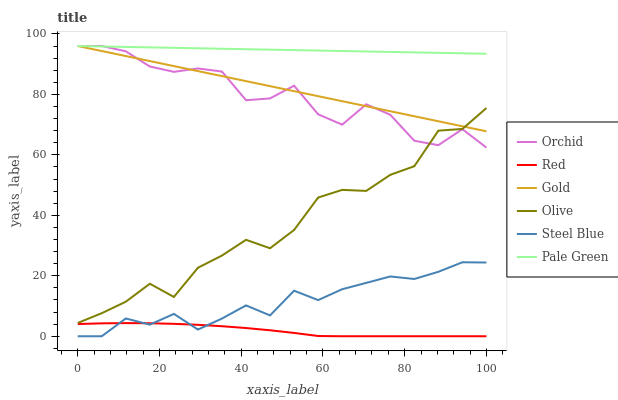Does Steel Blue have the minimum area under the curve?
Answer yes or no. No. Does Steel Blue have the maximum area under the curve?
Answer yes or no. No. Is Steel Blue the smoothest?
Answer yes or no. No. Is Steel Blue the roughest?
Answer yes or no. No. Does Pale Green have the lowest value?
Answer yes or no. No. Does Steel Blue have the highest value?
Answer yes or no. No. Is Steel Blue less than Olive?
Answer yes or no. Yes. Is Orchid greater than Steel Blue?
Answer yes or no. Yes. Does Steel Blue intersect Olive?
Answer yes or no. No. 